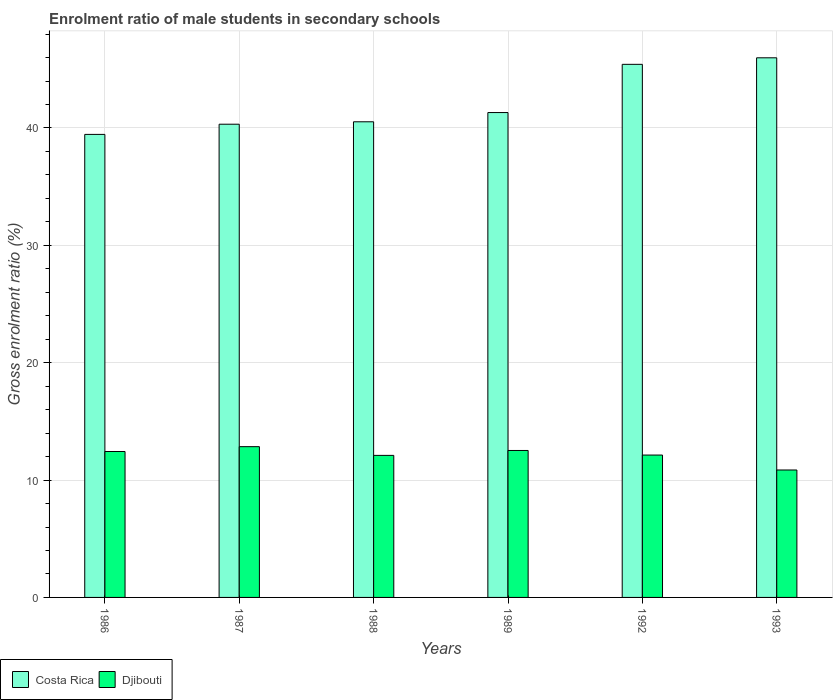Are the number of bars on each tick of the X-axis equal?
Provide a succinct answer. Yes. How many bars are there on the 6th tick from the right?
Your answer should be compact. 2. What is the label of the 3rd group of bars from the left?
Provide a short and direct response. 1988. What is the enrolment ratio of male students in secondary schools in Costa Rica in 1988?
Your response must be concise. 40.53. Across all years, what is the maximum enrolment ratio of male students in secondary schools in Djibouti?
Offer a terse response. 12.85. Across all years, what is the minimum enrolment ratio of male students in secondary schools in Djibouti?
Provide a short and direct response. 10.86. What is the total enrolment ratio of male students in secondary schools in Djibouti in the graph?
Provide a short and direct response. 72.89. What is the difference between the enrolment ratio of male students in secondary schools in Costa Rica in 1988 and that in 1992?
Provide a succinct answer. -4.89. What is the difference between the enrolment ratio of male students in secondary schools in Costa Rica in 1988 and the enrolment ratio of male students in secondary schools in Djibouti in 1986?
Your response must be concise. 28.09. What is the average enrolment ratio of male students in secondary schools in Costa Rica per year?
Your response must be concise. 42.17. In the year 1986, what is the difference between the enrolment ratio of male students in secondary schools in Costa Rica and enrolment ratio of male students in secondary schools in Djibouti?
Provide a short and direct response. 27.02. In how many years, is the enrolment ratio of male students in secondary schools in Costa Rica greater than 46 %?
Your answer should be very brief. 0. What is the ratio of the enrolment ratio of male students in secondary schools in Costa Rica in 1986 to that in 1992?
Provide a short and direct response. 0.87. Is the difference between the enrolment ratio of male students in secondary schools in Costa Rica in 1986 and 1987 greater than the difference between the enrolment ratio of male students in secondary schools in Djibouti in 1986 and 1987?
Provide a succinct answer. No. What is the difference between the highest and the second highest enrolment ratio of male students in secondary schools in Costa Rica?
Provide a succinct answer. 0.56. What is the difference between the highest and the lowest enrolment ratio of male students in secondary schools in Djibouti?
Offer a very short reply. 1.99. What does the 2nd bar from the left in 1992 represents?
Your answer should be compact. Djibouti. What does the 1st bar from the right in 1993 represents?
Offer a very short reply. Djibouti. What is the difference between two consecutive major ticks on the Y-axis?
Offer a terse response. 10. Are the values on the major ticks of Y-axis written in scientific E-notation?
Your response must be concise. No. Does the graph contain any zero values?
Your answer should be compact. No. Does the graph contain grids?
Your answer should be compact. Yes. How many legend labels are there?
Make the answer very short. 2. What is the title of the graph?
Give a very brief answer. Enrolment ratio of male students in secondary schools. What is the label or title of the X-axis?
Your answer should be compact. Years. What is the Gross enrolment ratio (%) of Costa Rica in 1986?
Make the answer very short. 39.45. What is the Gross enrolment ratio (%) in Djibouti in 1986?
Your answer should be very brief. 12.43. What is the Gross enrolment ratio (%) in Costa Rica in 1987?
Offer a very short reply. 40.32. What is the Gross enrolment ratio (%) in Djibouti in 1987?
Your answer should be very brief. 12.85. What is the Gross enrolment ratio (%) of Costa Rica in 1988?
Offer a very short reply. 40.53. What is the Gross enrolment ratio (%) in Djibouti in 1988?
Your answer should be compact. 12.1. What is the Gross enrolment ratio (%) of Costa Rica in 1989?
Your answer should be very brief. 41.31. What is the Gross enrolment ratio (%) in Djibouti in 1989?
Provide a short and direct response. 12.52. What is the Gross enrolment ratio (%) of Costa Rica in 1992?
Your response must be concise. 45.42. What is the Gross enrolment ratio (%) in Djibouti in 1992?
Ensure brevity in your answer.  12.13. What is the Gross enrolment ratio (%) in Costa Rica in 1993?
Your answer should be compact. 45.98. What is the Gross enrolment ratio (%) of Djibouti in 1993?
Offer a very short reply. 10.86. Across all years, what is the maximum Gross enrolment ratio (%) in Costa Rica?
Ensure brevity in your answer.  45.98. Across all years, what is the maximum Gross enrolment ratio (%) in Djibouti?
Offer a terse response. 12.85. Across all years, what is the minimum Gross enrolment ratio (%) in Costa Rica?
Your answer should be compact. 39.45. Across all years, what is the minimum Gross enrolment ratio (%) of Djibouti?
Offer a very short reply. 10.86. What is the total Gross enrolment ratio (%) of Costa Rica in the graph?
Keep it short and to the point. 253.01. What is the total Gross enrolment ratio (%) of Djibouti in the graph?
Keep it short and to the point. 72.89. What is the difference between the Gross enrolment ratio (%) in Costa Rica in 1986 and that in 1987?
Provide a short and direct response. -0.87. What is the difference between the Gross enrolment ratio (%) of Djibouti in 1986 and that in 1987?
Ensure brevity in your answer.  -0.41. What is the difference between the Gross enrolment ratio (%) of Costa Rica in 1986 and that in 1988?
Ensure brevity in your answer.  -1.07. What is the difference between the Gross enrolment ratio (%) of Djibouti in 1986 and that in 1988?
Your response must be concise. 0.33. What is the difference between the Gross enrolment ratio (%) of Costa Rica in 1986 and that in 1989?
Your answer should be compact. -1.86. What is the difference between the Gross enrolment ratio (%) of Djibouti in 1986 and that in 1989?
Your answer should be compact. -0.09. What is the difference between the Gross enrolment ratio (%) of Costa Rica in 1986 and that in 1992?
Your response must be concise. -5.97. What is the difference between the Gross enrolment ratio (%) in Djibouti in 1986 and that in 1992?
Offer a terse response. 0.3. What is the difference between the Gross enrolment ratio (%) in Costa Rica in 1986 and that in 1993?
Ensure brevity in your answer.  -6.53. What is the difference between the Gross enrolment ratio (%) of Djibouti in 1986 and that in 1993?
Make the answer very short. 1.57. What is the difference between the Gross enrolment ratio (%) in Costa Rica in 1987 and that in 1988?
Ensure brevity in your answer.  -0.21. What is the difference between the Gross enrolment ratio (%) in Djibouti in 1987 and that in 1988?
Ensure brevity in your answer.  0.74. What is the difference between the Gross enrolment ratio (%) in Costa Rica in 1987 and that in 1989?
Offer a terse response. -0.99. What is the difference between the Gross enrolment ratio (%) of Djibouti in 1987 and that in 1989?
Provide a short and direct response. 0.33. What is the difference between the Gross enrolment ratio (%) in Costa Rica in 1987 and that in 1992?
Keep it short and to the point. -5.1. What is the difference between the Gross enrolment ratio (%) of Djibouti in 1987 and that in 1992?
Offer a terse response. 0.71. What is the difference between the Gross enrolment ratio (%) of Costa Rica in 1987 and that in 1993?
Provide a succinct answer. -5.66. What is the difference between the Gross enrolment ratio (%) of Djibouti in 1987 and that in 1993?
Your response must be concise. 1.99. What is the difference between the Gross enrolment ratio (%) in Costa Rica in 1988 and that in 1989?
Your answer should be very brief. -0.79. What is the difference between the Gross enrolment ratio (%) in Djibouti in 1988 and that in 1989?
Your response must be concise. -0.42. What is the difference between the Gross enrolment ratio (%) in Costa Rica in 1988 and that in 1992?
Offer a terse response. -4.89. What is the difference between the Gross enrolment ratio (%) of Djibouti in 1988 and that in 1992?
Keep it short and to the point. -0.03. What is the difference between the Gross enrolment ratio (%) in Costa Rica in 1988 and that in 1993?
Your response must be concise. -5.45. What is the difference between the Gross enrolment ratio (%) in Djibouti in 1988 and that in 1993?
Offer a terse response. 1.24. What is the difference between the Gross enrolment ratio (%) in Costa Rica in 1989 and that in 1992?
Make the answer very short. -4.11. What is the difference between the Gross enrolment ratio (%) of Djibouti in 1989 and that in 1992?
Offer a terse response. 0.39. What is the difference between the Gross enrolment ratio (%) in Costa Rica in 1989 and that in 1993?
Give a very brief answer. -4.67. What is the difference between the Gross enrolment ratio (%) in Djibouti in 1989 and that in 1993?
Your response must be concise. 1.66. What is the difference between the Gross enrolment ratio (%) in Costa Rica in 1992 and that in 1993?
Keep it short and to the point. -0.56. What is the difference between the Gross enrolment ratio (%) in Djibouti in 1992 and that in 1993?
Offer a terse response. 1.27. What is the difference between the Gross enrolment ratio (%) of Costa Rica in 1986 and the Gross enrolment ratio (%) of Djibouti in 1987?
Give a very brief answer. 26.61. What is the difference between the Gross enrolment ratio (%) of Costa Rica in 1986 and the Gross enrolment ratio (%) of Djibouti in 1988?
Ensure brevity in your answer.  27.35. What is the difference between the Gross enrolment ratio (%) of Costa Rica in 1986 and the Gross enrolment ratio (%) of Djibouti in 1989?
Provide a succinct answer. 26.93. What is the difference between the Gross enrolment ratio (%) in Costa Rica in 1986 and the Gross enrolment ratio (%) in Djibouti in 1992?
Provide a short and direct response. 27.32. What is the difference between the Gross enrolment ratio (%) of Costa Rica in 1986 and the Gross enrolment ratio (%) of Djibouti in 1993?
Your answer should be compact. 28.59. What is the difference between the Gross enrolment ratio (%) in Costa Rica in 1987 and the Gross enrolment ratio (%) in Djibouti in 1988?
Your response must be concise. 28.22. What is the difference between the Gross enrolment ratio (%) of Costa Rica in 1987 and the Gross enrolment ratio (%) of Djibouti in 1989?
Provide a short and direct response. 27.8. What is the difference between the Gross enrolment ratio (%) of Costa Rica in 1987 and the Gross enrolment ratio (%) of Djibouti in 1992?
Ensure brevity in your answer.  28.19. What is the difference between the Gross enrolment ratio (%) of Costa Rica in 1987 and the Gross enrolment ratio (%) of Djibouti in 1993?
Make the answer very short. 29.46. What is the difference between the Gross enrolment ratio (%) in Costa Rica in 1988 and the Gross enrolment ratio (%) in Djibouti in 1989?
Your answer should be compact. 28.01. What is the difference between the Gross enrolment ratio (%) of Costa Rica in 1988 and the Gross enrolment ratio (%) of Djibouti in 1992?
Give a very brief answer. 28.4. What is the difference between the Gross enrolment ratio (%) in Costa Rica in 1988 and the Gross enrolment ratio (%) in Djibouti in 1993?
Your response must be concise. 29.67. What is the difference between the Gross enrolment ratio (%) of Costa Rica in 1989 and the Gross enrolment ratio (%) of Djibouti in 1992?
Offer a very short reply. 29.18. What is the difference between the Gross enrolment ratio (%) of Costa Rica in 1989 and the Gross enrolment ratio (%) of Djibouti in 1993?
Your answer should be compact. 30.45. What is the difference between the Gross enrolment ratio (%) in Costa Rica in 1992 and the Gross enrolment ratio (%) in Djibouti in 1993?
Make the answer very short. 34.56. What is the average Gross enrolment ratio (%) in Costa Rica per year?
Ensure brevity in your answer.  42.17. What is the average Gross enrolment ratio (%) in Djibouti per year?
Give a very brief answer. 12.15. In the year 1986, what is the difference between the Gross enrolment ratio (%) of Costa Rica and Gross enrolment ratio (%) of Djibouti?
Give a very brief answer. 27.02. In the year 1987, what is the difference between the Gross enrolment ratio (%) in Costa Rica and Gross enrolment ratio (%) in Djibouti?
Your answer should be compact. 27.47. In the year 1988, what is the difference between the Gross enrolment ratio (%) in Costa Rica and Gross enrolment ratio (%) in Djibouti?
Your response must be concise. 28.42. In the year 1989, what is the difference between the Gross enrolment ratio (%) of Costa Rica and Gross enrolment ratio (%) of Djibouti?
Give a very brief answer. 28.79. In the year 1992, what is the difference between the Gross enrolment ratio (%) of Costa Rica and Gross enrolment ratio (%) of Djibouti?
Ensure brevity in your answer.  33.29. In the year 1993, what is the difference between the Gross enrolment ratio (%) of Costa Rica and Gross enrolment ratio (%) of Djibouti?
Keep it short and to the point. 35.12. What is the ratio of the Gross enrolment ratio (%) of Costa Rica in 1986 to that in 1987?
Give a very brief answer. 0.98. What is the ratio of the Gross enrolment ratio (%) of Djibouti in 1986 to that in 1987?
Your answer should be compact. 0.97. What is the ratio of the Gross enrolment ratio (%) in Costa Rica in 1986 to that in 1988?
Offer a very short reply. 0.97. What is the ratio of the Gross enrolment ratio (%) in Djibouti in 1986 to that in 1988?
Ensure brevity in your answer.  1.03. What is the ratio of the Gross enrolment ratio (%) of Costa Rica in 1986 to that in 1989?
Offer a terse response. 0.95. What is the ratio of the Gross enrolment ratio (%) of Djibouti in 1986 to that in 1989?
Ensure brevity in your answer.  0.99. What is the ratio of the Gross enrolment ratio (%) in Costa Rica in 1986 to that in 1992?
Your answer should be very brief. 0.87. What is the ratio of the Gross enrolment ratio (%) in Djibouti in 1986 to that in 1992?
Your answer should be compact. 1.02. What is the ratio of the Gross enrolment ratio (%) of Costa Rica in 1986 to that in 1993?
Your answer should be compact. 0.86. What is the ratio of the Gross enrolment ratio (%) of Djibouti in 1986 to that in 1993?
Provide a succinct answer. 1.15. What is the ratio of the Gross enrolment ratio (%) of Djibouti in 1987 to that in 1988?
Offer a terse response. 1.06. What is the ratio of the Gross enrolment ratio (%) in Costa Rica in 1987 to that in 1989?
Provide a succinct answer. 0.98. What is the ratio of the Gross enrolment ratio (%) in Djibouti in 1987 to that in 1989?
Your answer should be very brief. 1.03. What is the ratio of the Gross enrolment ratio (%) of Costa Rica in 1987 to that in 1992?
Provide a succinct answer. 0.89. What is the ratio of the Gross enrolment ratio (%) in Djibouti in 1987 to that in 1992?
Offer a terse response. 1.06. What is the ratio of the Gross enrolment ratio (%) of Costa Rica in 1987 to that in 1993?
Give a very brief answer. 0.88. What is the ratio of the Gross enrolment ratio (%) in Djibouti in 1987 to that in 1993?
Ensure brevity in your answer.  1.18. What is the ratio of the Gross enrolment ratio (%) in Djibouti in 1988 to that in 1989?
Ensure brevity in your answer.  0.97. What is the ratio of the Gross enrolment ratio (%) of Costa Rica in 1988 to that in 1992?
Your answer should be compact. 0.89. What is the ratio of the Gross enrolment ratio (%) in Djibouti in 1988 to that in 1992?
Offer a very short reply. 1. What is the ratio of the Gross enrolment ratio (%) in Costa Rica in 1988 to that in 1993?
Your answer should be compact. 0.88. What is the ratio of the Gross enrolment ratio (%) of Djibouti in 1988 to that in 1993?
Offer a very short reply. 1.11. What is the ratio of the Gross enrolment ratio (%) of Costa Rica in 1989 to that in 1992?
Offer a very short reply. 0.91. What is the ratio of the Gross enrolment ratio (%) of Djibouti in 1989 to that in 1992?
Your response must be concise. 1.03. What is the ratio of the Gross enrolment ratio (%) in Costa Rica in 1989 to that in 1993?
Ensure brevity in your answer.  0.9. What is the ratio of the Gross enrolment ratio (%) of Djibouti in 1989 to that in 1993?
Keep it short and to the point. 1.15. What is the ratio of the Gross enrolment ratio (%) of Costa Rica in 1992 to that in 1993?
Provide a short and direct response. 0.99. What is the ratio of the Gross enrolment ratio (%) of Djibouti in 1992 to that in 1993?
Make the answer very short. 1.12. What is the difference between the highest and the second highest Gross enrolment ratio (%) of Costa Rica?
Offer a terse response. 0.56. What is the difference between the highest and the second highest Gross enrolment ratio (%) in Djibouti?
Make the answer very short. 0.33. What is the difference between the highest and the lowest Gross enrolment ratio (%) in Costa Rica?
Your response must be concise. 6.53. What is the difference between the highest and the lowest Gross enrolment ratio (%) in Djibouti?
Give a very brief answer. 1.99. 